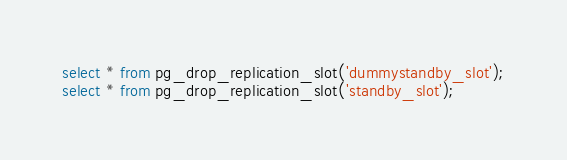Convert code to text. <code><loc_0><loc_0><loc_500><loc_500><_SQL_>
select * from pg_drop_replication_slot('dummystandby_slot');
select * from pg_drop_replication_slot('standby_slot');</code> 